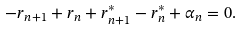Convert formula to latex. <formula><loc_0><loc_0><loc_500><loc_500>- r _ { n + 1 } + r _ { n } + r ^ { * } _ { n + 1 } - r ^ { * } _ { n } + \alpha _ { n } = 0 .</formula> 